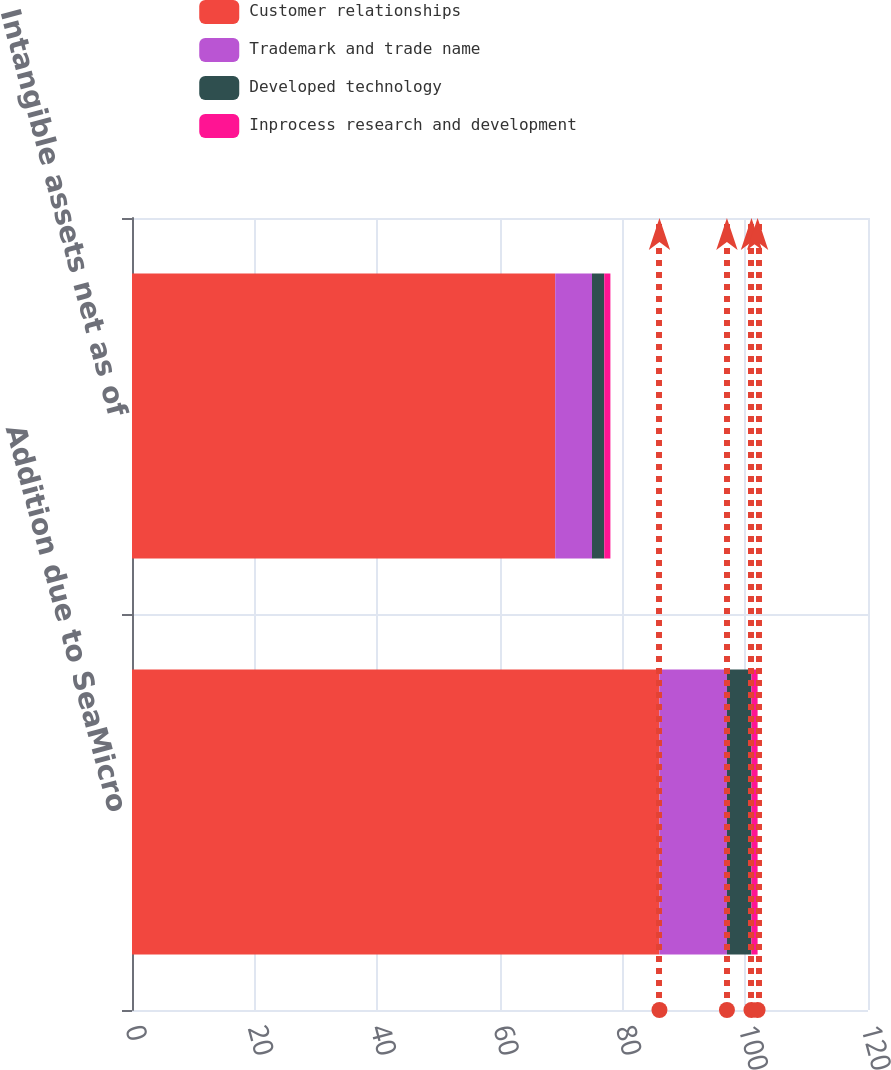Convert chart to OTSL. <chart><loc_0><loc_0><loc_500><loc_500><stacked_bar_chart><ecel><fcel>Addition due to SeaMicro<fcel>Intangible assets net as of<nl><fcel>Customer relationships<fcel>86<fcel>69<nl><fcel>Trademark and trade name<fcel>11<fcel>6<nl><fcel>Developed technology<fcel>4<fcel>2<nl><fcel>Inprocess research and development<fcel>1<fcel>1<nl></chart> 